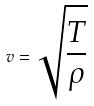<formula> <loc_0><loc_0><loc_500><loc_500>v = \sqrt { \frac { T } { \rho } }</formula> 